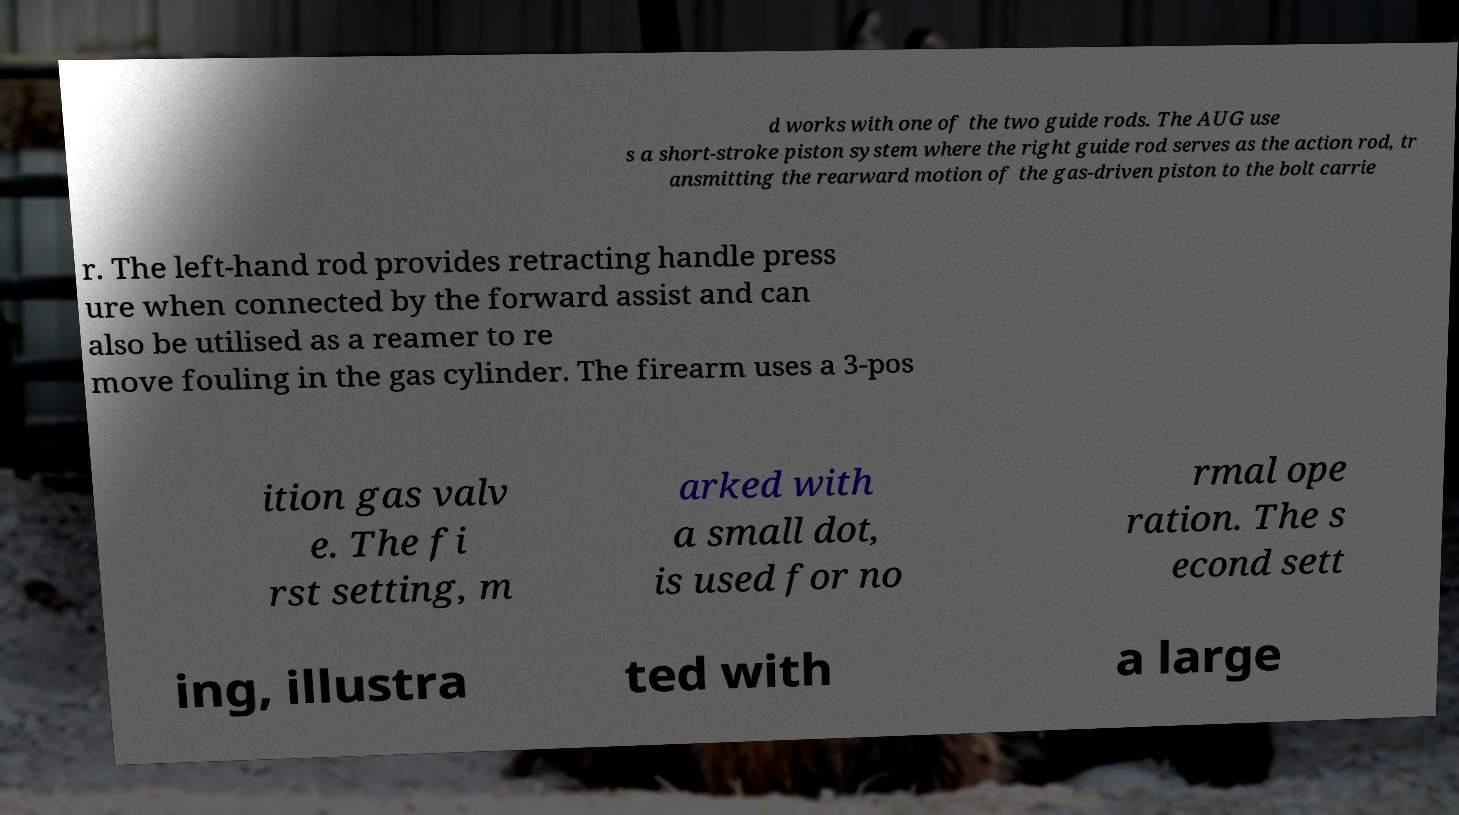Could you extract and type out the text from this image? d works with one of the two guide rods. The AUG use s a short-stroke piston system where the right guide rod serves as the action rod, tr ansmitting the rearward motion of the gas-driven piston to the bolt carrie r. The left-hand rod provides retracting handle press ure when connected by the forward assist and can also be utilised as a reamer to re move fouling in the gas cylinder. The firearm uses a 3-pos ition gas valv e. The fi rst setting, m arked with a small dot, is used for no rmal ope ration. The s econd sett ing, illustra ted with a large 